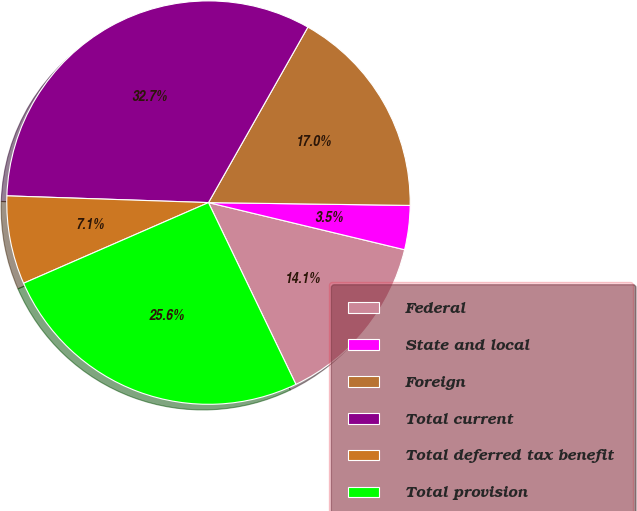Convert chart. <chart><loc_0><loc_0><loc_500><loc_500><pie_chart><fcel>Federal<fcel>State and local<fcel>Foreign<fcel>Total current<fcel>Total deferred tax benefit<fcel>Total provision<nl><fcel>14.11%<fcel>3.53%<fcel>17.02%<fcel>32.67%<fcel>7.08%<fcel>25.59%<nl></chart> 